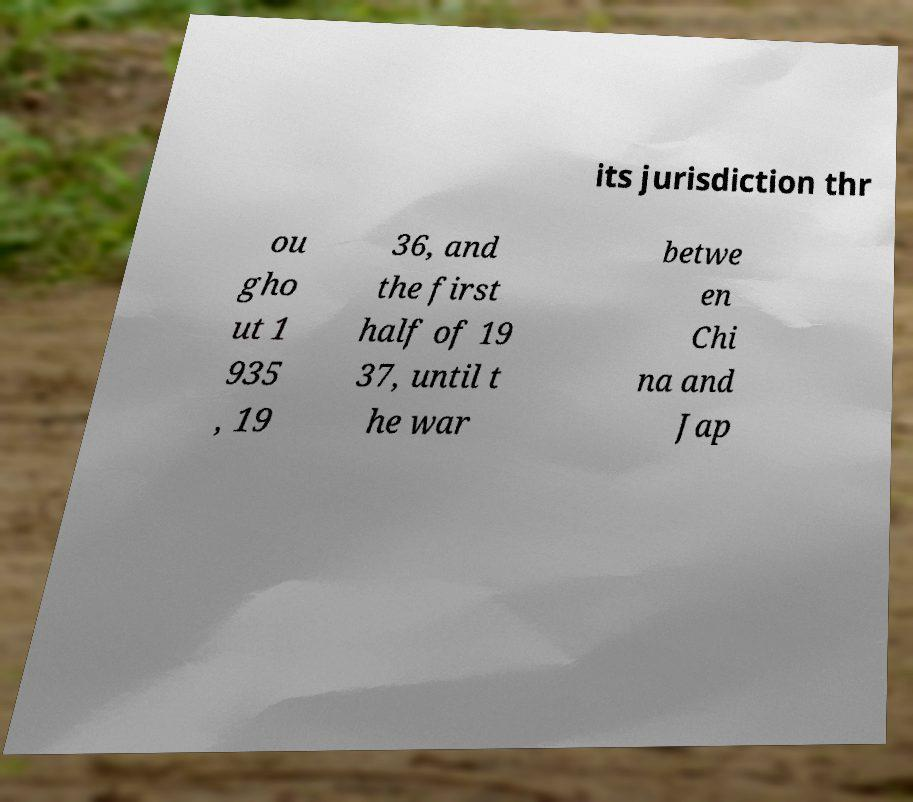There's text embedded in this image that I need extracted. Can you transcribe it verbatim? its jurisdiction thr ou gho ut 1 935 , 19 36, and the first half of 19 37, until t he war betwe en Chi na and Jap 